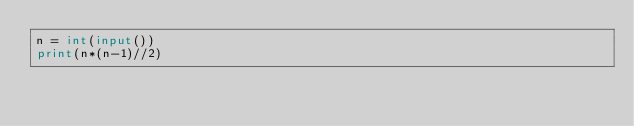Convert code to text. <code><loc_0><loc_0><loc_500><loc_500><_Python_>n = int(input())
print(n*(n-1)//2)</code> 